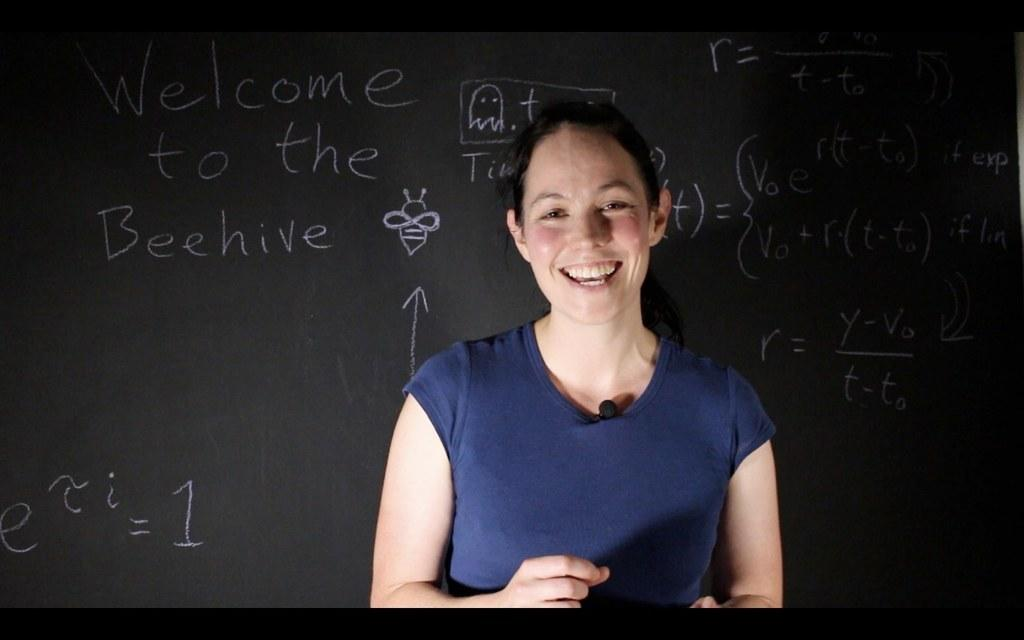Who is present in the image? There is a woman in the image. What is the woman wearing? The woman is wearing a violet-colored T-shirt. What is the woman's facial expression? The woman is smiling. What can be seen in the background of the image? There is a black color board in the background. What is written on the black color board? There are white color texts on the black color board. Does the woman have a friend with her in the image? The provided facts do not mention the presence of a friend, so we cannot determine if the woman has a friend with her in the image. What is the friction coefficient of the woman's violet-colored T-shirt? The provided facts do not include any information about the friction coefficient of the woman's T-shirt, so we cannot determine its friction coefficient. 